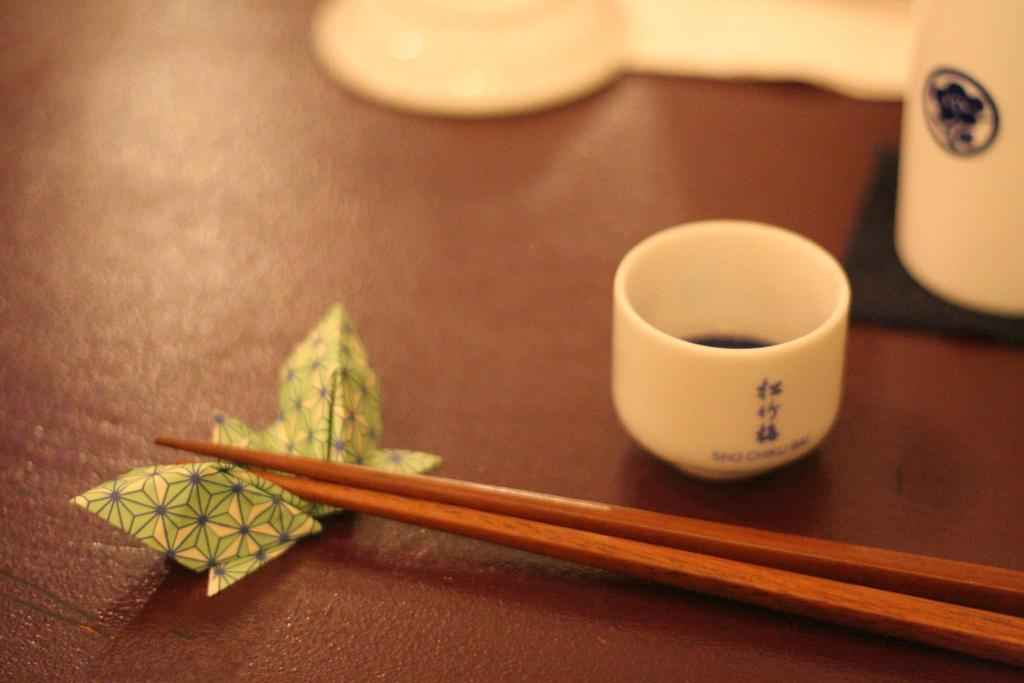What type of container is present in the image? There is a cup and a glass in the image. What other objects can be seen in the image? There is a saucer and chopsticks in the image. What decorative item is present in the image? There is a paper butterfly in the image. Where are these objects placed? The objects are placed on a table. What covers the table in the image? There is a tablecloth on the table. What type of mailbox can be seen in the image? There is no mailbox present in the image; it features a cup, glass, saucer, chopsticks, paper butterfly, table, and tablecloth. 